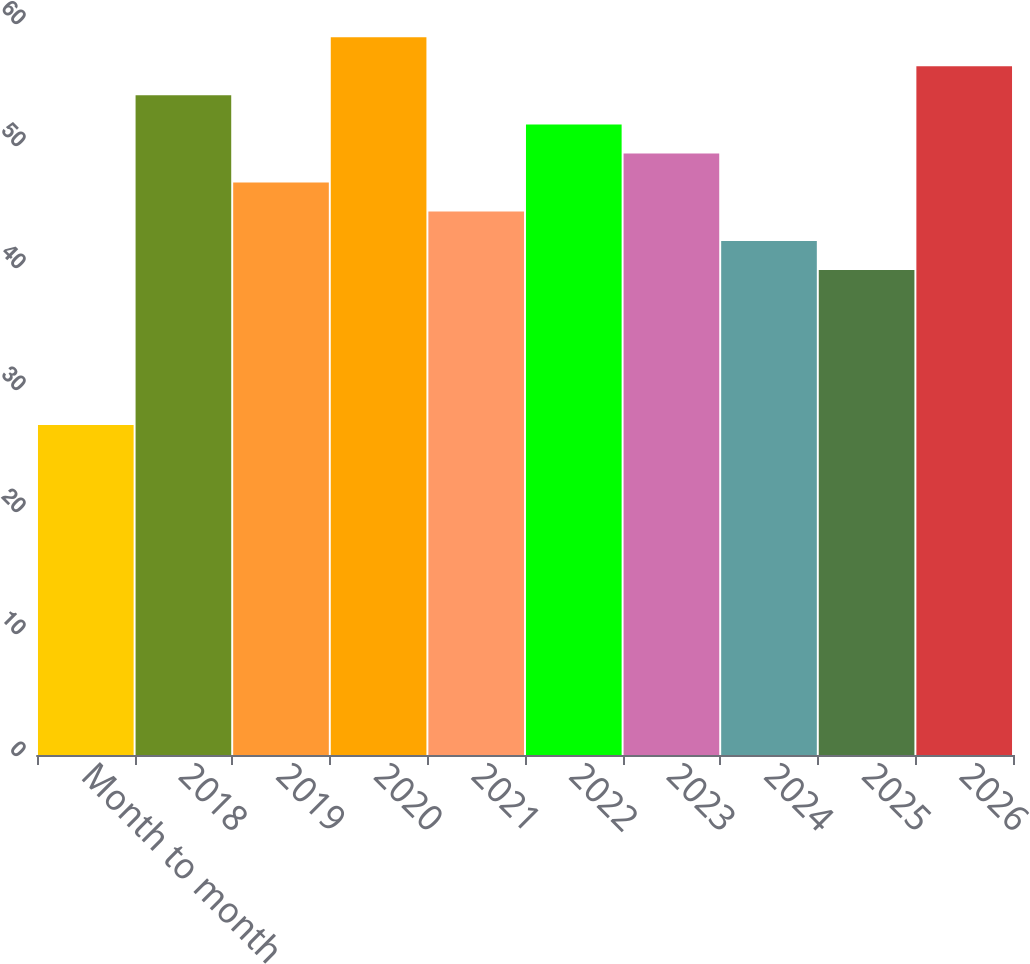Convert chart to OTSL. <chart><loc_0><loc_0><loc_500><loc_500><bar_chart><fcel>Month to month<fcel>2018<fcel>2019<fcel>2020<fcel>2021<fcel>2022<fcel>2023<fcel>2024<fcel>2025<fcel>2026<nl><fcel>27.05<fcel>54.07<fcel>46.93<fcel>58.83<fcel>44.55<fcel>51.69<fcel>49.31<fcel>42.14<fcel>39.76<fcel>56.45<nl></chart> 